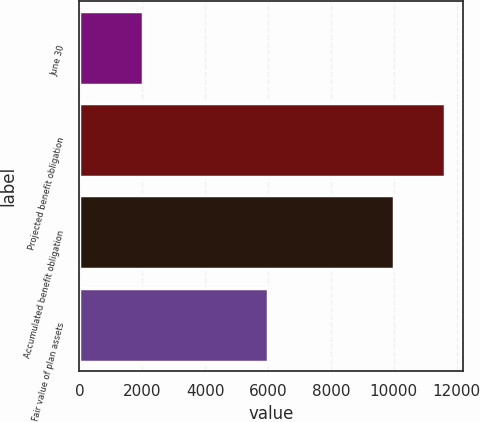<chart> <loc_0><loc_0><loc_500><loc_500><bar_chart><fcel>June 30<fcel>Projected benefit obligation<fcel>Accumulated benefit obligation<fcel>Fair value of plan assets<nl><fcel>2012<fcel>11623<fcel>10009<fcel>6013<nl></chart> 